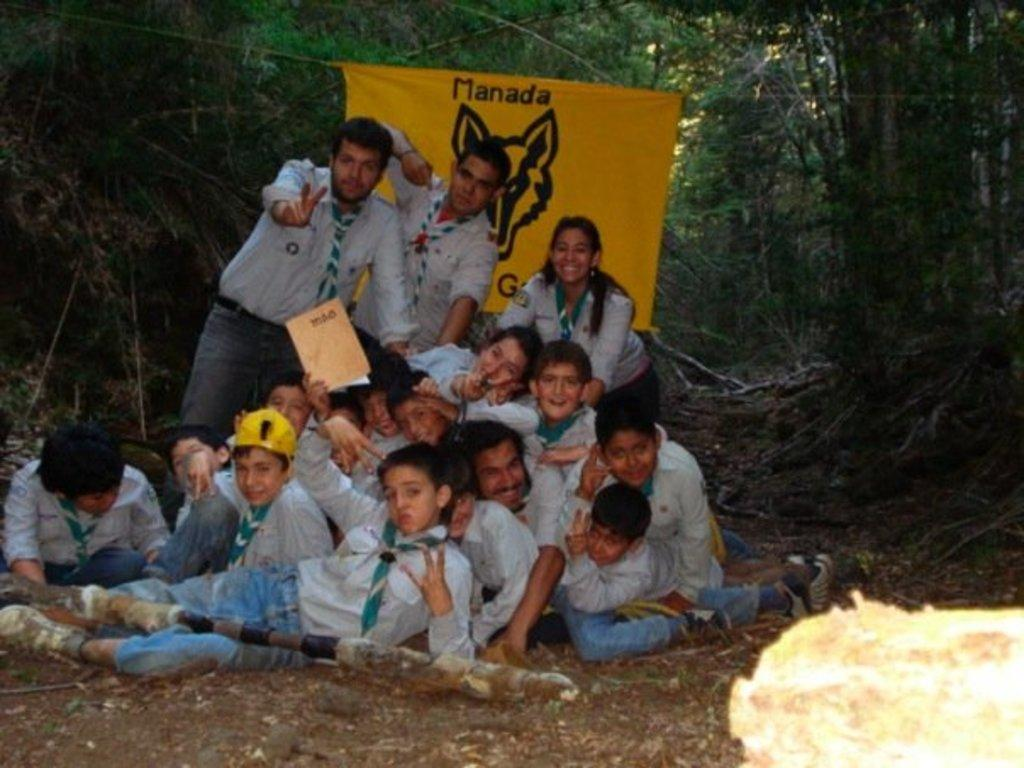What is the main subject of the image? The main subject of the image is a group of children. What are the children doing in the image? The children are posing for a photo. What can be seen behind the children? There is a banner behind the children, and trees are visible behind the banner. What type of dock can be seen in the image? There is no dock present in the image. What form does the appliance take in the image? There is no appliance present in the image. 